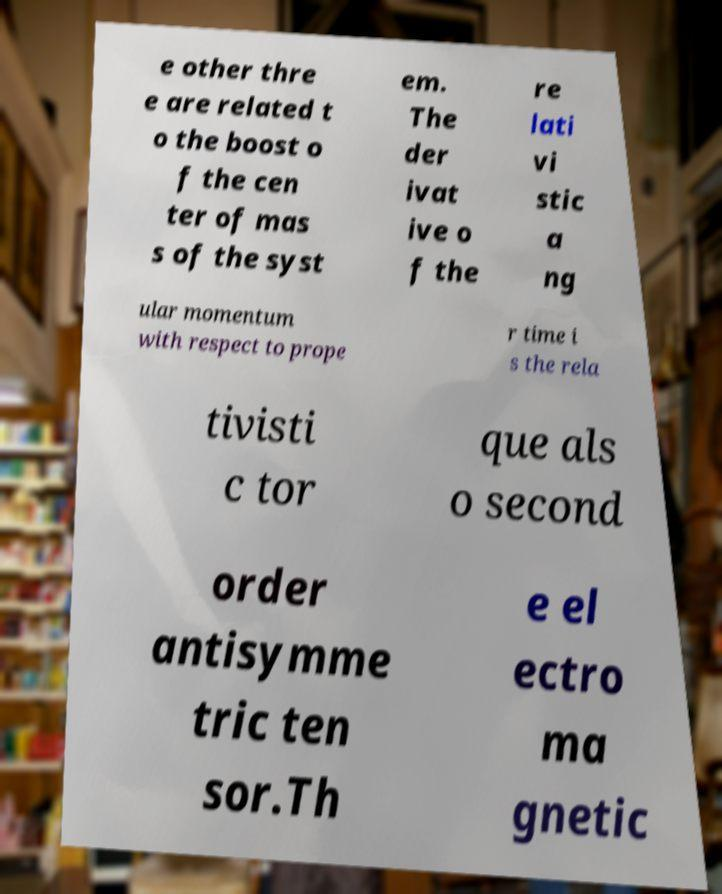Could you assist in decoding the text presented in this image and type it out clearly? e other thre e are related t o the boost o f the cen ter of mas s of the syst em. The der ivat ive o f the re lati vi stic a ng ular momentum with respect to prope r time i s the rela tivisti c tor que als o second order antisymme tric ten sor.Th e el ectro ma gnetic 